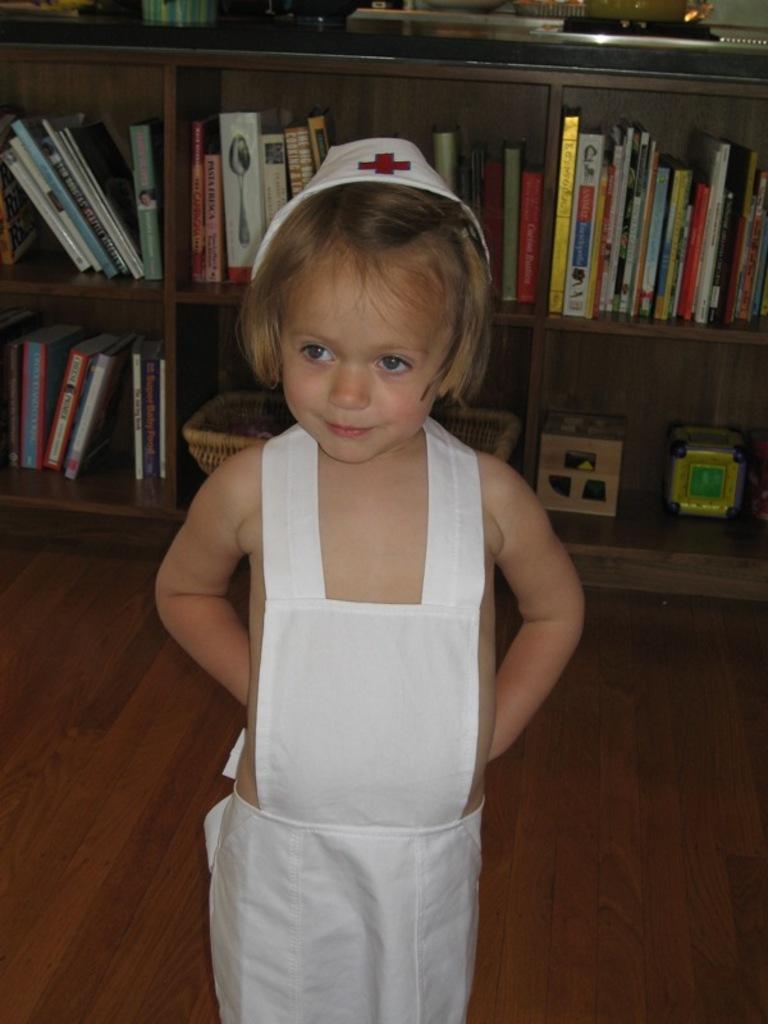In one or two sentences, can you explain what this image depicts? In the center of the image we can see a girl standing. She is wearing a white dress. In the background there is a shelf and we can see books placed in the shelf. At the bottom there is floor. 